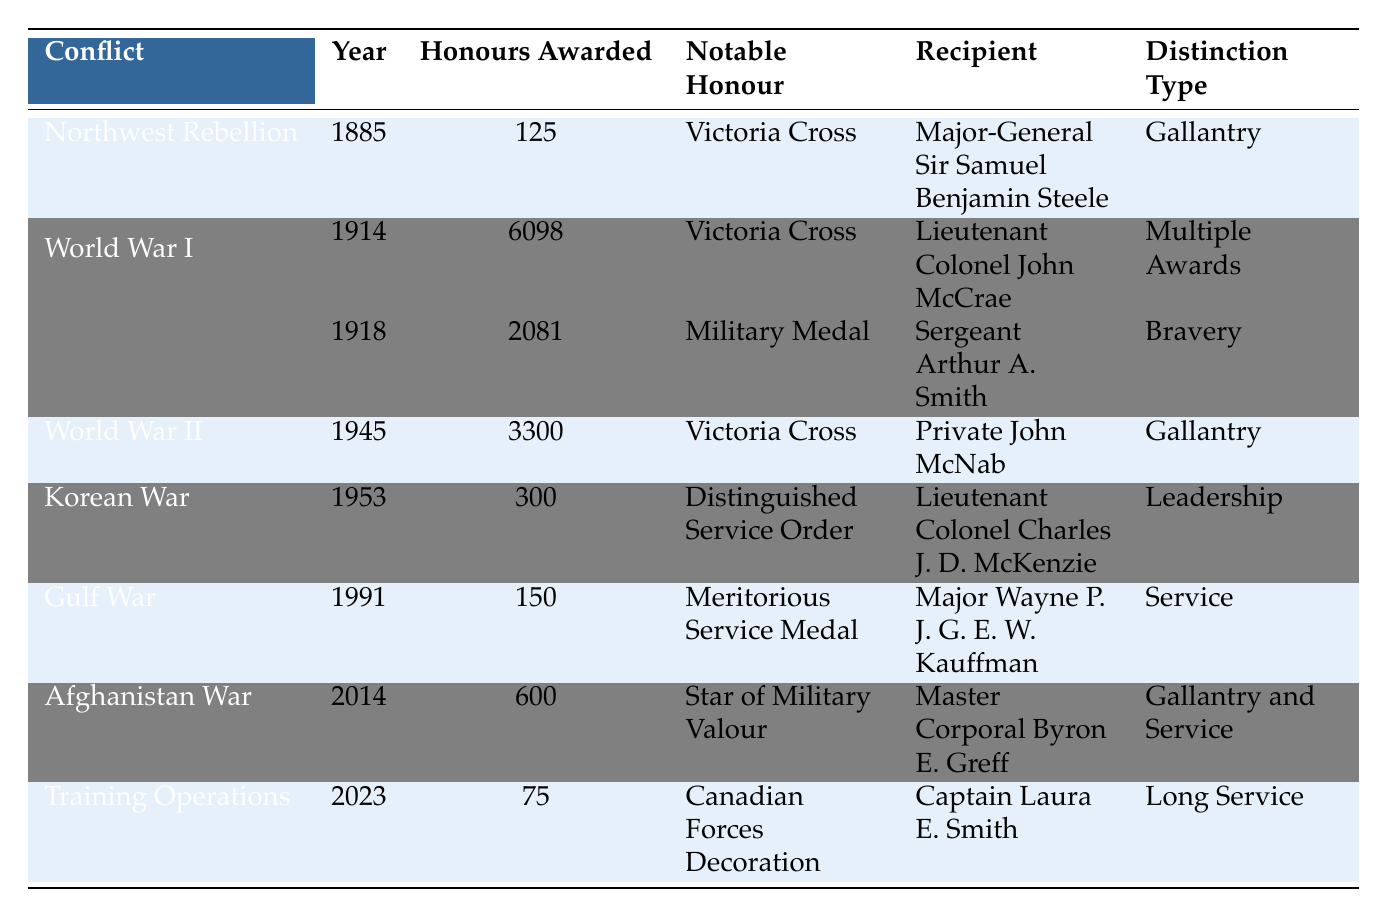What was the total number of honours awarded during World War I? To find the total number of honours awarded during World War I, I need to sum the honours awarded in the years 1914 and 1918. This totals 6098 (in 1914) + 2081 (in 1918) = 8179.
Answer: 8179 Which notable honour was awarded the most during the conflicts listed? Looking through the table, the "Victoria Cross" was awarded in both 1885 (Northwest Rebellion) and 1945 (World War II), and it was the notable honour for 6098 awards in 1914 and 3300 in 1945. This is the most mentioned honour throughout the table.
Answer: Victoria Cross Was the total number of honours awarded in 2014 greater than the total in 2023? The data shows that in 2014, 600 honours were awarded, while in 2023, only 75 were awarded. Since 600 is greater than 75, the statement is true.
Answer: Yes Which conflict in 1945 had notable gallantry awards? In 1945, the World War II conflict had 3300 honours awarded, with the notable honour being the Victoria Cross, awarded for gallantry, as indicated by the distinct title.
Answer: World War II What is the average number of honours awarded per conflict from 1885 to 2023? There are 7 conflicts listed in total. To find the average, I will sum all the honours awarded from each conflict: 125 + 6098 + 2081 + 3300 + 300 + 150 + 600 + 75 = 8789. I will then divide this sum by 7 (the number of conflicts): 8789 / 7 = 1255.57, which rounds to approximately 1256.
Answer: 1256 How many honours awarded were for leadership distinction type? Upon examining the table, I see that the only entry that mentions "Leadership" as a distinction type is the one for the Korean War in 1953, which had 300 honours awarded. There are no other distinctions listed as "Leadership."
Answer: 300 